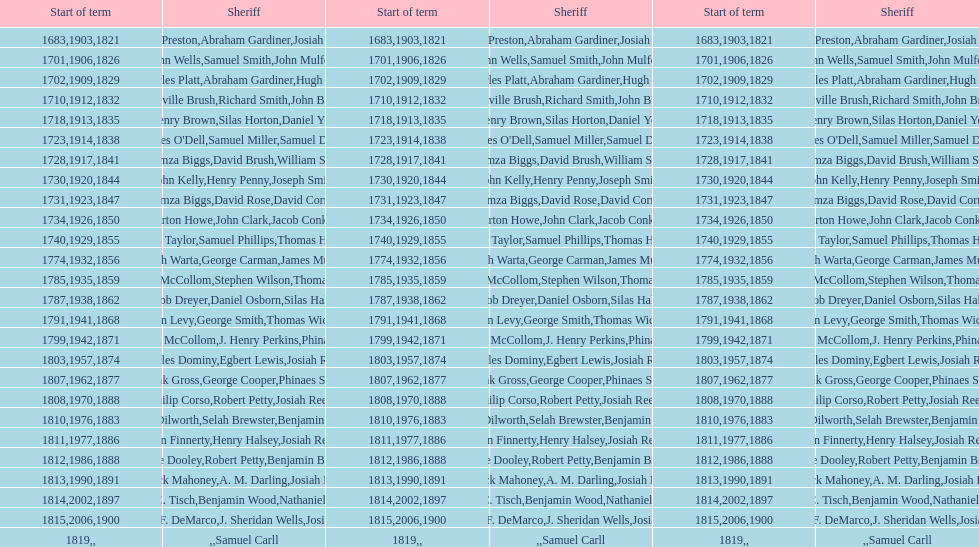When did benjamin brewster serve his second term? 1812. 